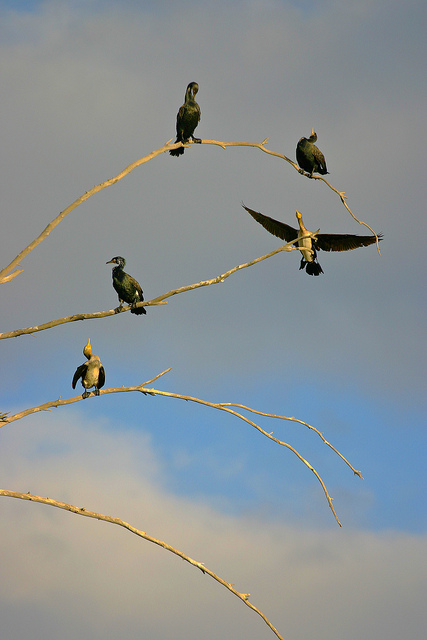What time of day does this scene appear to depict? The warm tones and soft lighting suggest this tranquil scene likely occurs during the late afternoon, near the golden hour. 